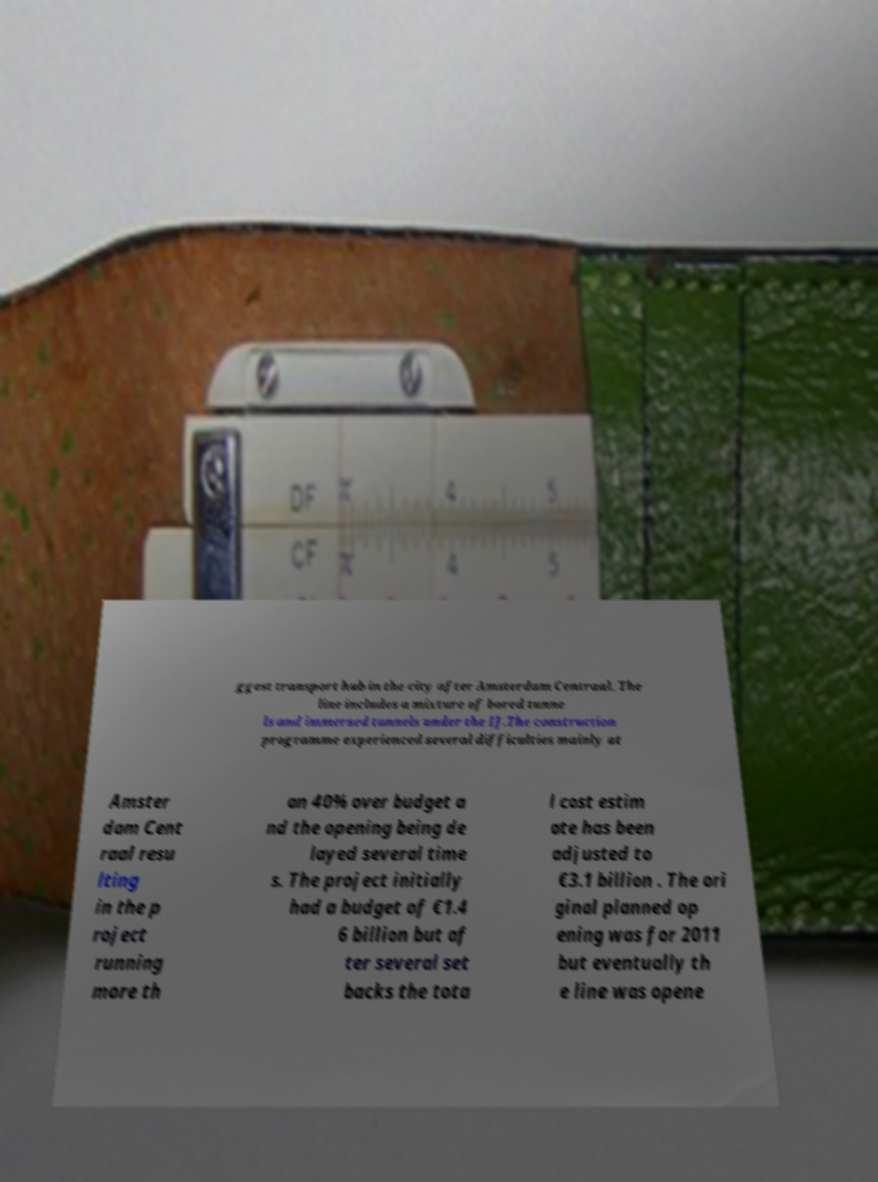Please read and relay the text visible in this image. What does it say? ggest transport hub in the city after Amsterdam Centraal. The line includes a mixture of bored tunne ls and immersed tunnels under the IJ.The construction programme experienced several difficulties mainly at Amster dam Cent raal resu lting in the p roject running more th an 40% over budget a nd the opening being de layed several time s. The project initially had a budget of €1.4 6 billion but af ter several set backs the tota l cost estim ate has been adjusted to €3.1 billion . The ori ginal planned op ening was for 2011 but eventually th e line was opene 